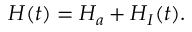Convert formula to latex. <formula><loc_0><loc_0><loc_500><loc_500>H ( t ) = H _ { a } + H _ { I } ( t ) .</formula> 